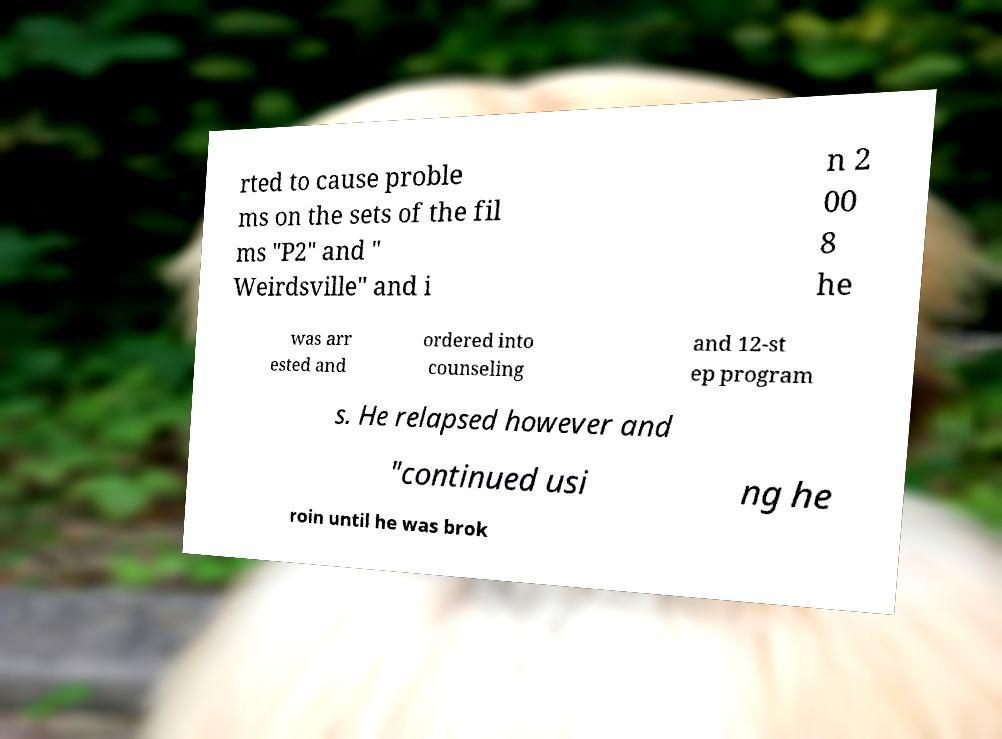I need the written content from this picture converted into text. Can you do that? rted to cause proble ms on the sets of the fil ms "P2" and " Weirdsville" and i n 2 00 8 he was arr ested and ordered into counseling and 12-st ep program s. He relapsed however and "continued usi ng he roin until he was brok 